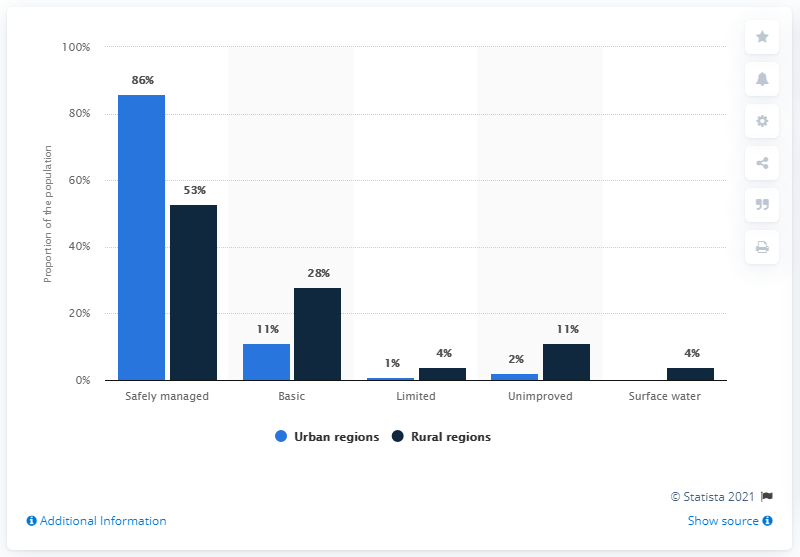Draw attention to some important aspects in this diagram. The region with the least difference between urban and rural areas is limited. In my opinion, urban regions are the most safely managed region. 